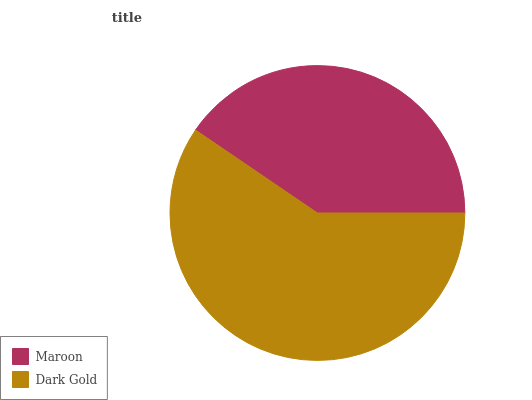Is Maroon the minimum?
Answer yes or no. Yes. Is Dark Gold the maximum?
Answer yes or no. Yes. Is Dark Gold the minimum?
Answer yes or no. No. Is Dark Gold greater than Maroon?
Answer yes or no. Yes. Is Maroon less than Dark Gold?
Answer yes or no. Yes. Is Maroon greater than Dark Gold?
Answer yes or no. No. Is Dark Gold less than Maroon?
Answer yes or no. No. Is Dark Gold the high median?
Answer yes or no. Yes. Is Maroon the low median?
Answer yes or no. Yes. Is Maroon the high median?
Answer yes or no. No. Is Dark Gold the low median?
Answer yes or no. No. 